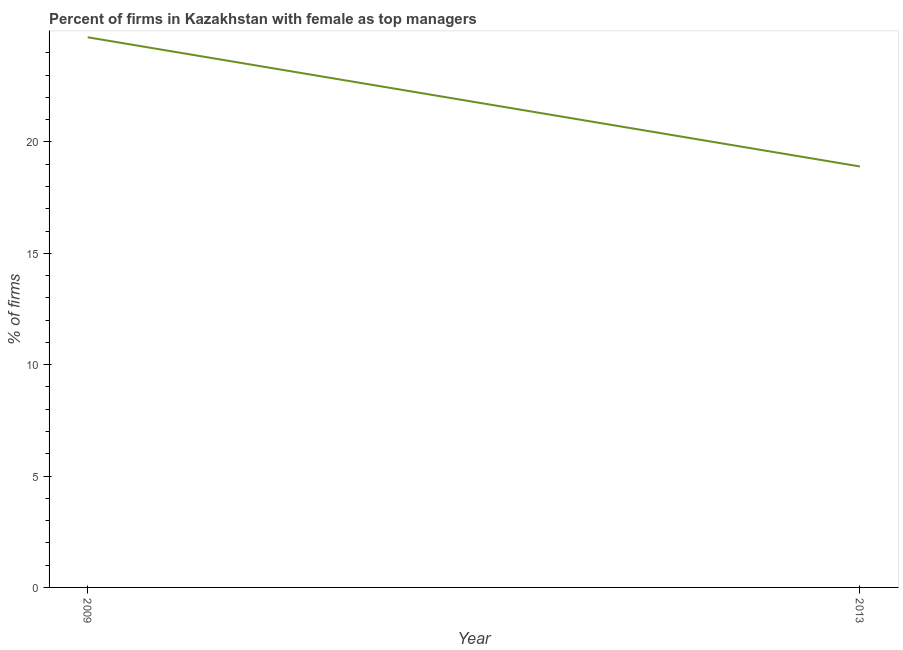What is the percentage of firms with female as top manager in 2009?
Your answer should be very brief. 24.7. Across all years, what is the maximum percentage of firms with female as top manager?
Keep it short and to the point. 24.7. Across all years, what is the minimum percentage of firms with female as top manager?
Keep it short and to the point. 18.9. What is the sum of the percentage of firms with female as top manager?
Your response must be concise. 43.6. What is the difference between the percentage of firms with female as top manager in 2009 and 2013?
Give a very brief answer. 5.8. What is the average percentage of firms with female as top manager per year?
Your answer should be compact. 21.8. What is the median percentage of firms with female as top manager?
Provide a succinct answer. 21.8. Do a majority of the years between 2013 and 2009 (inclusive) have percentage of firms with female as top manager greater than 4 %?
Offer a terse response. No. What is the ratio of the percentage of firms with female as top manager in 2009 to that in 2013?
Give a very brief answer. 1.31. In how many years, is the percentage of firms with female as top manager greater than the average percentage of firms with female as top manager taken over all years?
Your answer should be compact. 1. What is the difference between two consecutive major ticks on the Y-axis?
Your answer should be compact. 5. What is the title of the graph?
Make the answer very short. Percent of firms in Kazakhstan with female as top managers. What is the label or title of the X-axis?
Provide a short and direct response. Year. What is the label or title of the Y-axis?
Give a very brief answer. % of firms. What is the % of firms of 2009?
Give a very brief answer. 24.7. What is the % of firms in 2013?
Your answer should be very brief. 18.9. What is the difference between the % of firms in 2009 and 2013?
Make the answer very short. 5.8. What is the ratio of the % of firms in 2009 to that in 2013?
Your answer should be very brief. 1.31. 